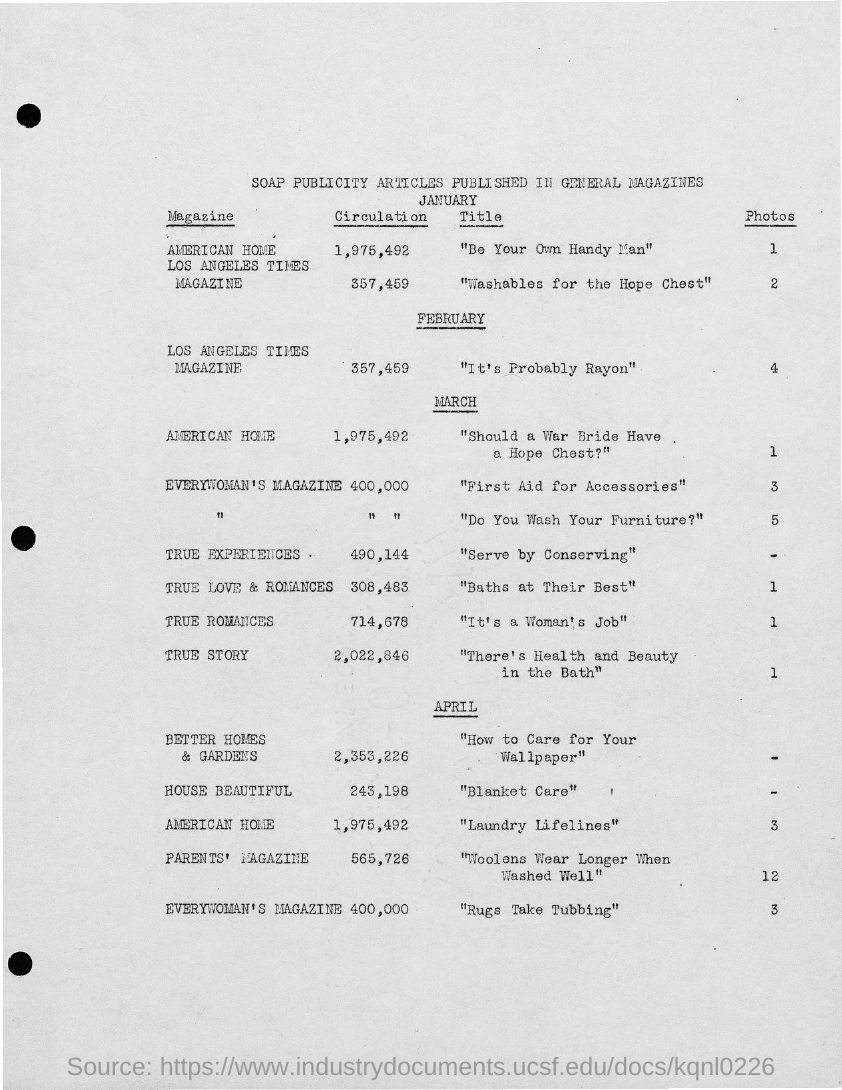What is the title of the document?
Your response must be concise. Soap Publicity articles published in General Magazines. 